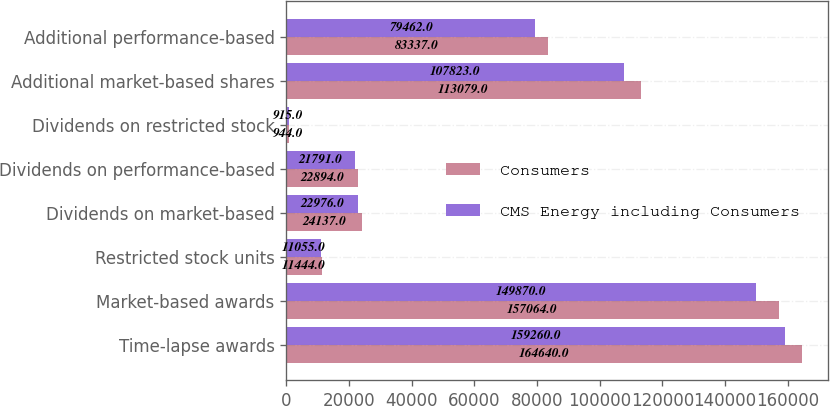Convert chart to OTSL. <chart><loc_0><loc_0><loc_500><loc_500><stacked_bar_chart><ecel><fcel>Time-lapse awards<fcel>Market-based awards<fcel>Restricted stock units<fcel>Dividends on market-based<fcel>Dividends on performance-based<fcel>Dividends on restricted stock<fcel>Additional market-based shares<fcel>Additional performance-based<nl><fcel>Consumers<fcel>164640<fcel>157064<fcel>11444<fcel>24137<fcel>22894<fcel>944<fcel>113079<fcel>83337<nl><fcel>CMS Energy including Consumers<fcel>159260<fcel>149870<fcel>11055<fcel>22976<fcel>21791<fcel>915<fcel>107823<fcel>79462<nl></chart> 